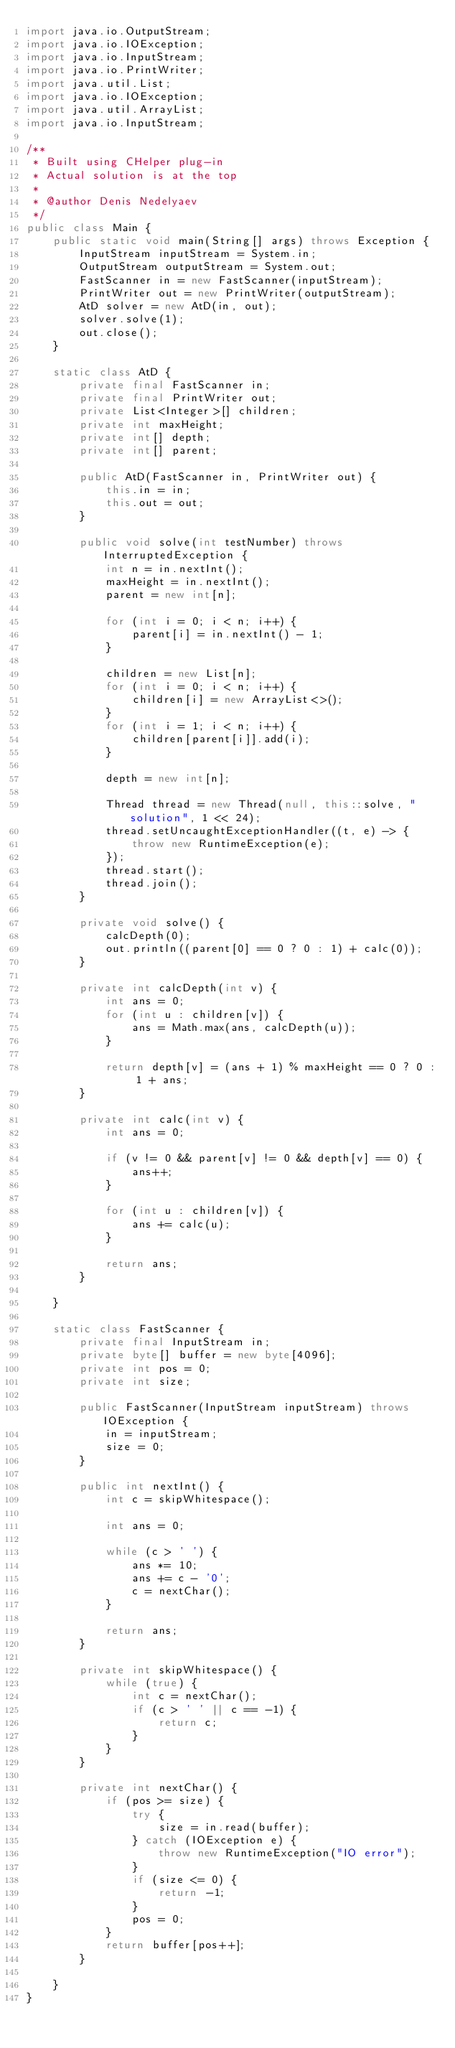<code> <loc_0><loc_0><loc_500><loc_500><_Java_>import java.io.OutputStream;
import java.io.IOException;
import java.io.InputStream;
import java.io.PrintWriter;
import java.util.List;
import java.io.IOException;
import java.util.ArrayList;
import java.io.InputStream;

/**
 * Built using CHelper plug-in
 * Actual solution is at the top
 *
 * @author Denis Nedelyaev
 */
public class Main {
    public static void main(String[] args) throws Exception {
        InputStream inputStream = System.in;
        OutputStream outputStream = System.out;
        FastScanner in = new FastScanner(inputStream);
        PrintWriter out = new PrintWriter(outputStream);
        AtD solver = new AtD(in, out);
        solver.solve(1);
        out.close();
    }

    static class AtD {
        private final FastScanner in;
        private final PrintWriter out;
        private List<Integer>[] children;
        private int maxHeight;
        private int[] depth;
        private int[] parent;

        public AtD(FastScanner in, PrintWriter out) {
            this.in = in;
            this.out = out;
        }

        public void solve(int testNumber) throws InterruptedException {
            int n = in.nextInt();
            maxHeight = in.nextInt();
            parent = new int[n];

            for (int i = 0; i < n; i++) {
                parent[i] = in.nextInt() - 1;
            }

            children = new List[n];
            for (int i = 0; i < n; i++) {
                children[i] = new ArrayList<>();
            }
            for (int i = 1; i < n; i++) {
                children[parent[i]].add(i);
            }

            depth = new int[n];

            Thread thread = new Thread(null, this::solve, "solution", 1 << 24);
            thread.setUncaughtExceptionHandler((t, e) -> {
                throw new RuntimeException(e);
            });
            thread.start();
            thread.join();
        }

        private void solve() {
            calcDepth(0);
            out.println((parent[0] == 0 ? 0 : 1) + calc(0));
        }

        private int calcDepth(int v) {
            int ans = 0;
            for (int u : children[v]) {
                ans = Math.max(ans, calcDepth(u));
            }

            return depth[v] = (ans + 1) % maxHeight == 0 ? 0 : 1 + ans;
        }

        private int calc(int v) {
            int ans = 0;

            if (v != 0 && parent[v] != 0 && depth[v] == 0) {
                ans++;
            }

            for (int u : children[v]) {
                ans += calc(u);
            }

            return ans;
        }

    }

    static class FastScanner {
        private final InputStream in;
        private byte[] buffer = new byte[4096];
        private int pos = 0;
        private int size;

        public FastScanner(InputStream inputStream) throws IOException {
            in = inputStream;
            size = 0;
        }

        public int nextInt() {
            int c = skipWhitespace();

            int ans = 0;

            while (c > ' ') {
                ans *= 10;
                ans += c - '0';
                c = nextChar();
            }

            return ans;
        }

        private int skipWhitespace() {
            while (true) {
                int c = nextChar();
                if (c > ' ' || c == -1) {
                    return c;
                }
            }
        }

        private int nextChar() {
            if (pos >= size) {
                try {
                    size = in.read(buffer);
                } catch (IOException e) {
                    throw new RuntimeException("IO error");
                }
                if (size <= 0) {
                    return -1;
                }
                pos = 0;
            }
            return buffer[pos++];
        }

    }
}

</code> 